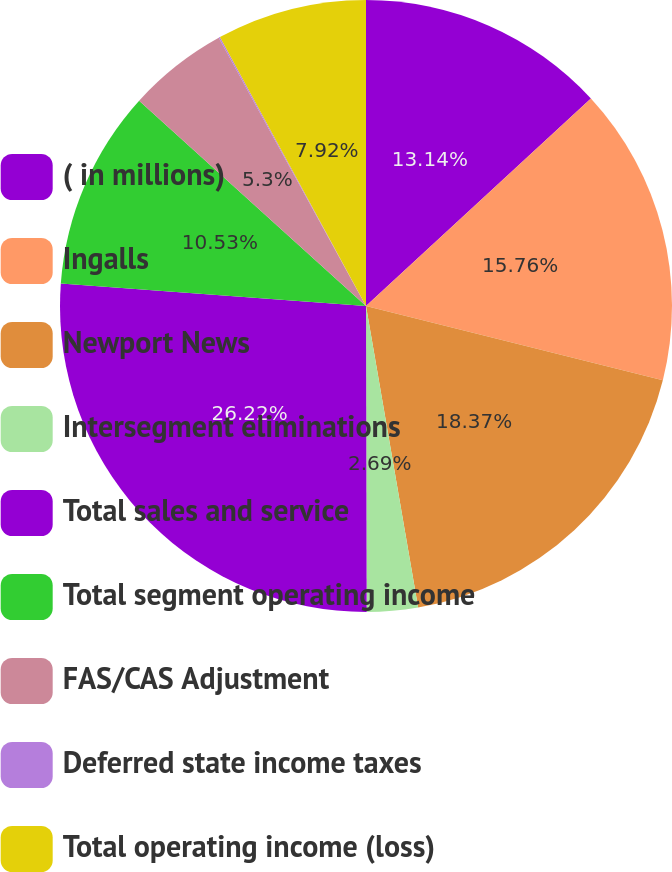Convert chart. <chart><loc_0><loc_0><loc_500><loc_500><pie_chart><fcel>( in millions)<fcel>Ingalls<fcel>Newport News<fcel>Intersegment eliminations<fcel>Total sales and service<fcel>Total segment operating income<fcel>FAS/CAS Adjustment<fcel>Deferred state income taxes<fcel>Total operating income (loss)<nl><fcel>13.14%<fcel>15.76%<fcel>18.37%<fcel>2.69%<fcel>26.21%<fcel>10.53%<fcel>5.3%<fcel>0.07%<fcel>7.92%<nl></chart> 